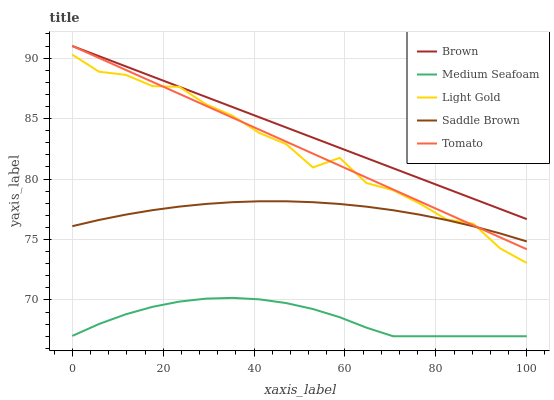Does Medium Seafoam have the minimum area under the curve?
Answer yes or no. Yes. Does Brown have the maximum area under the curve?
Answer yes or no. Yes. Does Light Gold have the minimum area under the curve?
Answer yes or no. No. Does Light Gold have the maximum area under the curve?
Answer yes or no. No. Is Tomato the smoothest?
Answer yes or no. Yes. Is Light Gold the roughest?
Answer yes or no. Yes. Is Brown the smoothest?
Answer yes or no. No. Is Brown the roughest?
Answer yes or no. No. Does Light Gold have the lowest value?
Answer yes or no. No. Does Brown have the highest value?
Answer yes or no. Yes. Does Light Gold have the highest value?
Answer yes or no. No. Is Medium Seafoam less than Tomato?
Answer yes or no. Yes. Is Brown greater than Saddle Brown?
Answer yes or no. Yes. Does Brown intersect Tomato?
Answer yes or no. Yes. Is Brown less than Tomato?
Answer yes or no. No. Is Brown greater than Tomato?
Answer yes or no. No. Does Medium Seafoam intersect Tomato?
Answer yes or no. No. 